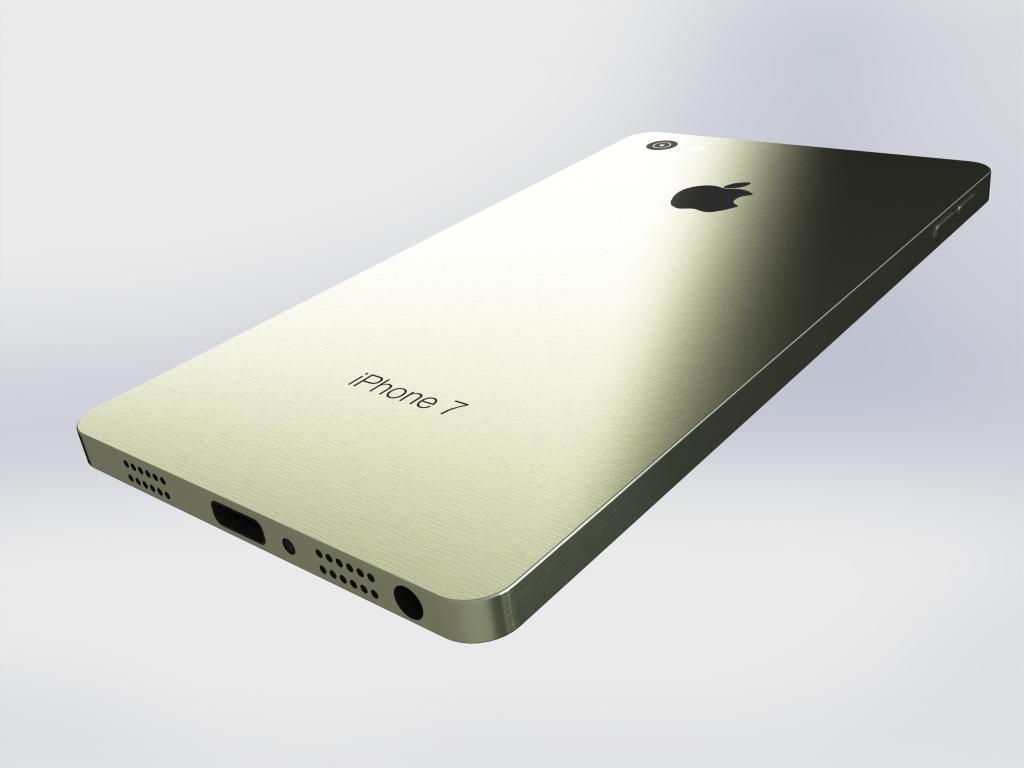This is a iphone 7?
Your answer should be very brief. Yes. 